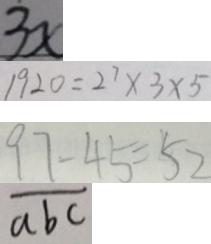<formula> <loc_0><loc_0><loc_500><loc_500>3 x 
 1 9 2 0 = 2 ^ { 7 } \times 3 \times 5 
 9 7 - 4 5 = 5 2 
 \overline { a b c }</formula> 